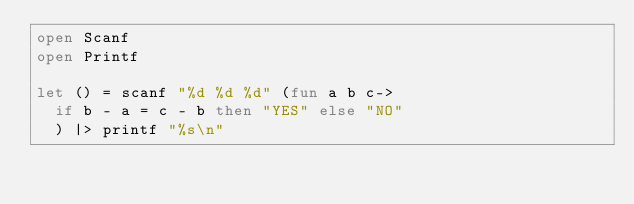Convert code to text. <code><loc_0><loc_0><loc_500><loc_500><_OCaml_>open Scanf
open Printf

let () = scanf "%d %d %d" (fun a b c->
  if b - a = c - b then "YES" else "NO"
  ) |> printf "%s\n"</code> 